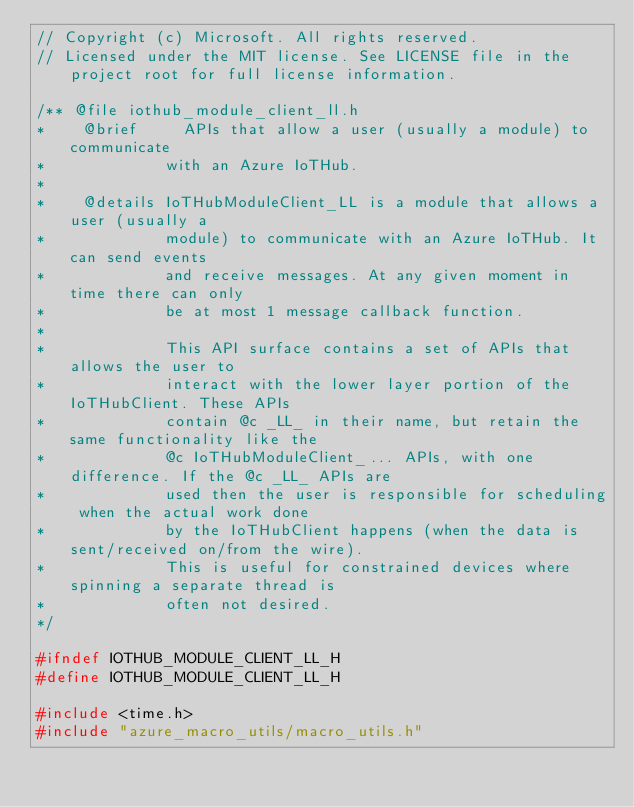Convert code to text. <code><loc_0><loc_0><loc_500><loc_500><_C_>// Copyright (c) Microsoft. All rights reserved.
// Licensed under the MIT license. See LICENSE file in the project root for full license information.

/** @file iothub_module_client_ll.h
*    @brief     APIs that allow a user (usually a module) to communicate
*             with an Azure IoTHub.
*
*    @details IoTHubModuleClient_LL is a module that allows a user (usually a
*             module) to communicate with an Azure IoTHub. It can send events
*             and receive messages. At any given moment in time there can only
*             be at most 1 message callback function.
*
*             This API surface contains a set of APIs that allows the user to
*             interact with the lower layer portion of the IoTHubClient. These APIs
*             contain @c _LL_ in their name, but retain the same functionality like the
*             @c IoTHubModuleClient_... APIs, with one difference. If the @c _LL_ APIs are
*             used then the user is responsible for scheduling when the actual work done
*             by the IoTHubClient happens (when the data is sent/received on/from the wire).
*             This is useful for constrained devices where spinning a separate thread is
*             often not desired.
*/

#ifndef IOTHUB_MODULE_CLIENT_LL_H
#define IOTHUB_MODULE_CLIENT_LL_H

#include <time.h>
#include "azure_macro_utils/macro_utils.h"</code> 